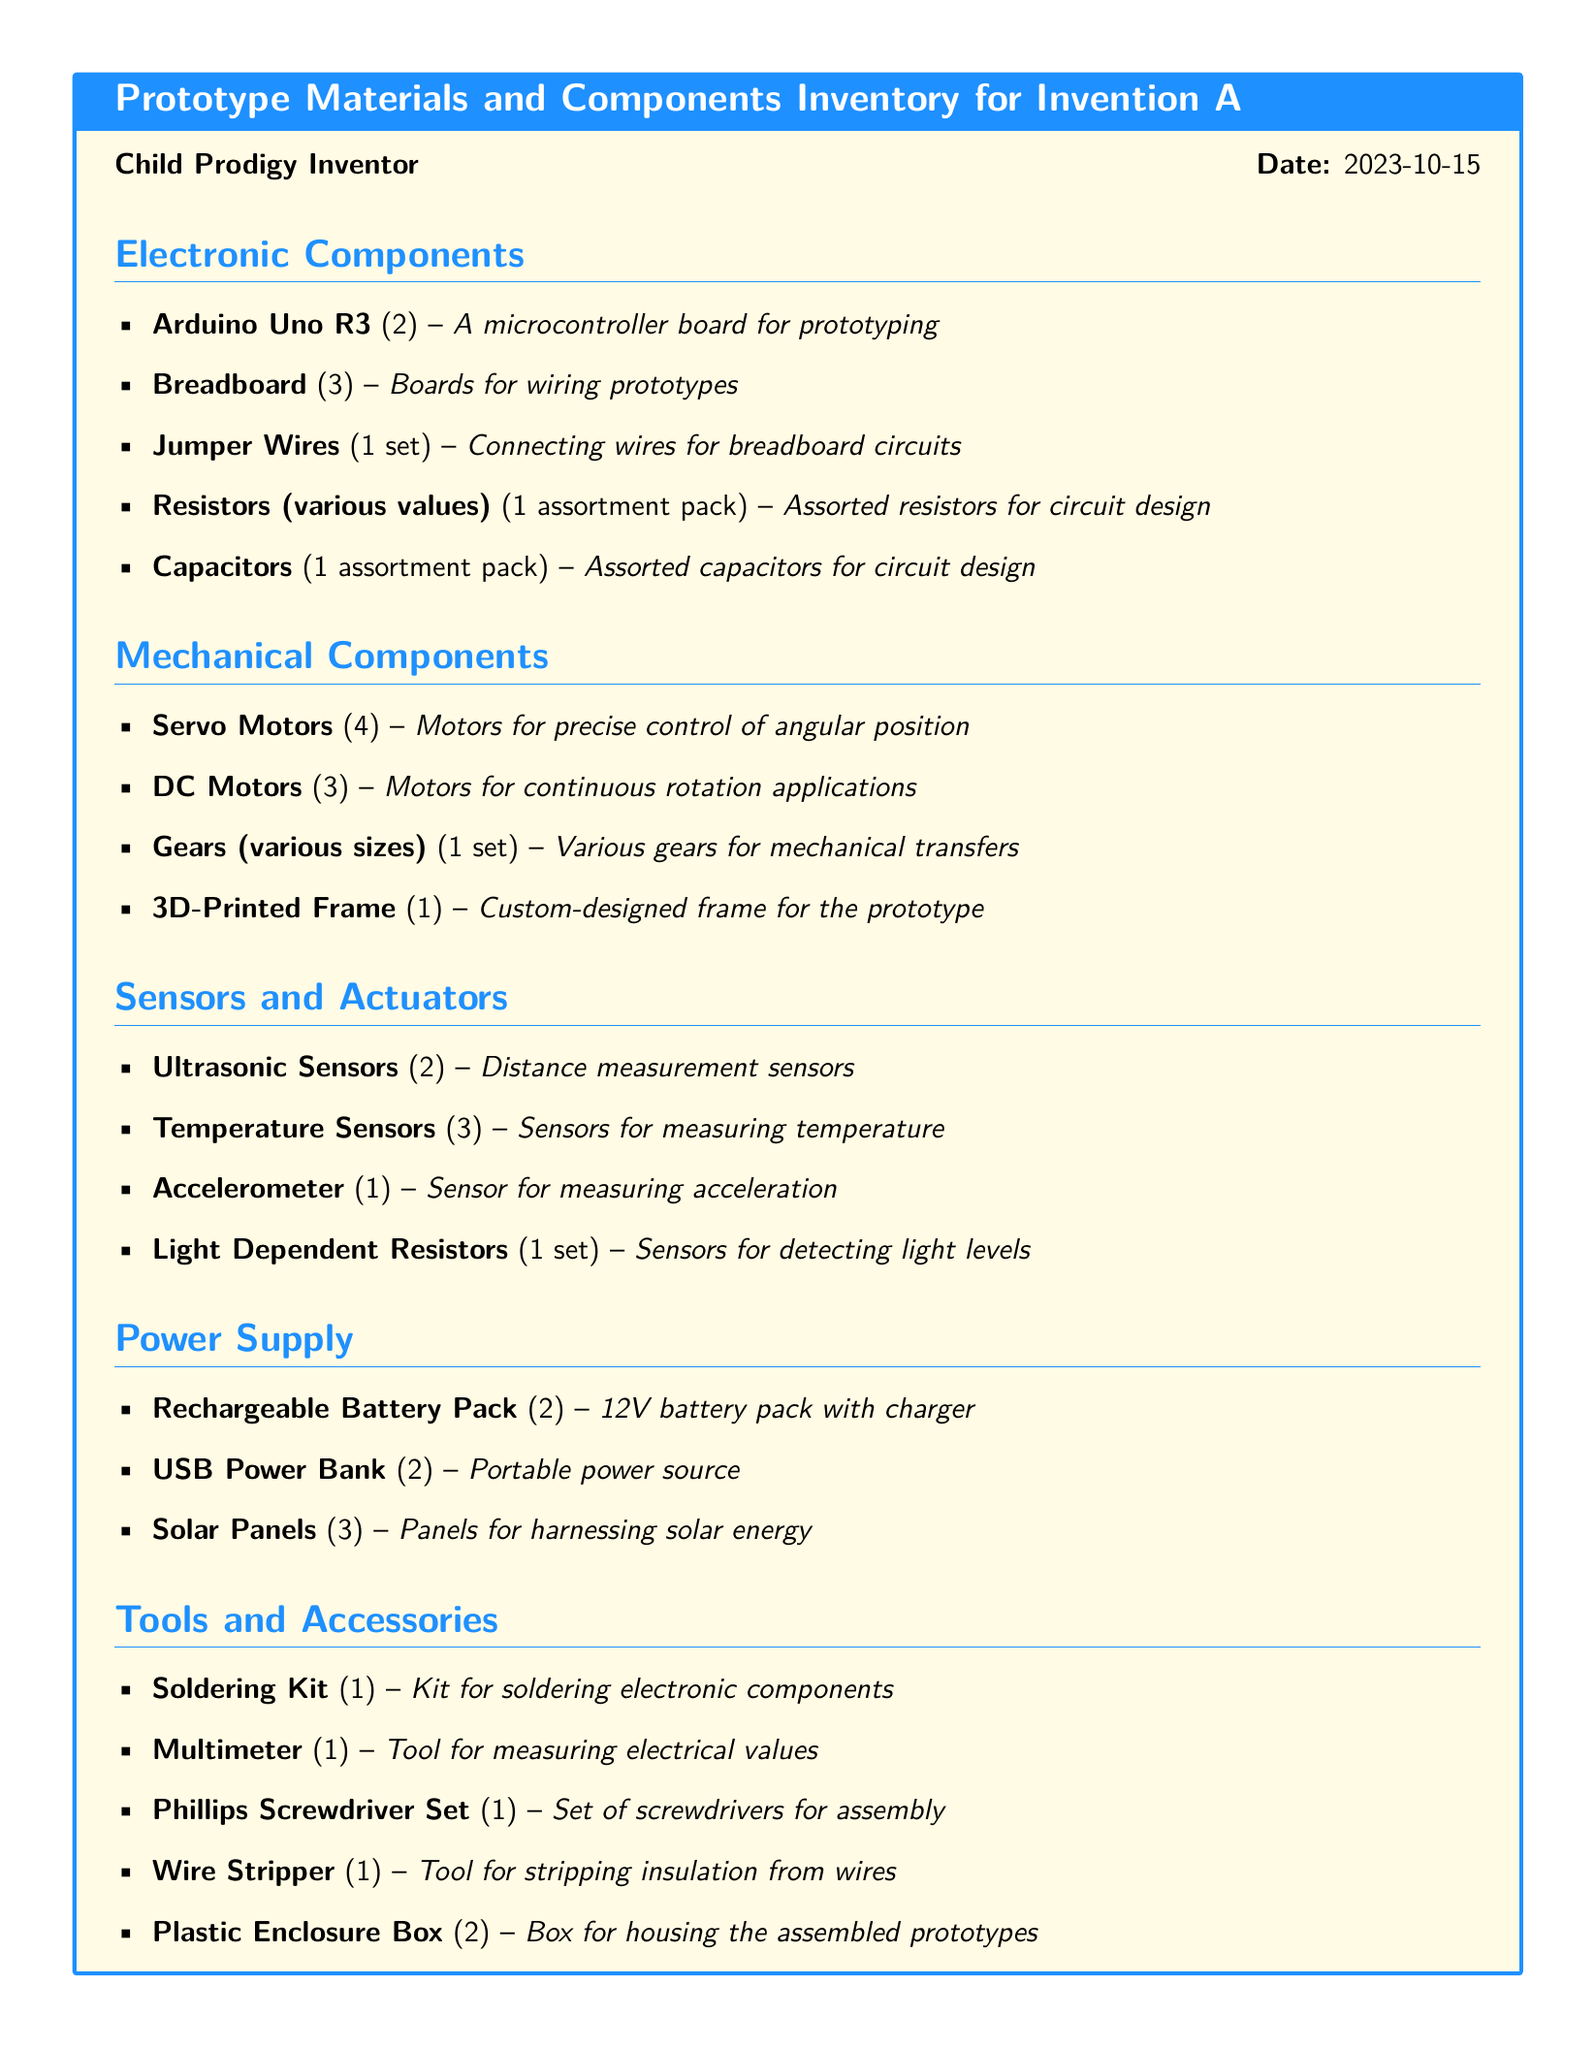What is the date of the inventory? The date is specified at the top of the document, indicating when the inventory was created.
Answer: 2023-10-15 How many Arduino Uno R3 boards are listed? The document states the quantity of Arduino Uno R3 boards under the Electronic Components section.
Answer: 2 What type of sensors are included in the inventory? The inventory includes various sensors listed under the Sensors and Actuators section, requiring an understanding of the listed items.
Answer: Ultrasonic Sensors, Temperature Sensors, Accelerometer, Light Dependent Resistors How many gears are in the inventory? The number of gears is included in the Mechanical Components section, which may imply a set rather than an exact count.
Answer: 1 set What is one tool listed in the Tools and Accessories section? The document outlines various tools and accessories, providing examples of what is available for assembling the prototype.
Answer: Soldering Kit How many Servo Motors are listed? The document provides a specific count of Servo Motors in the Mechanical Components section.
Answer: 4 What item is used for measuring electrical values? The document specifies a tool dedicated to measuring electrical values, indicating its purpose in prototyping.
Answer: Multimeter What type of power supply is a portable source? The inventory includes various power supply options, with at least one categorized as portable.
Answer: USB Power Bank 